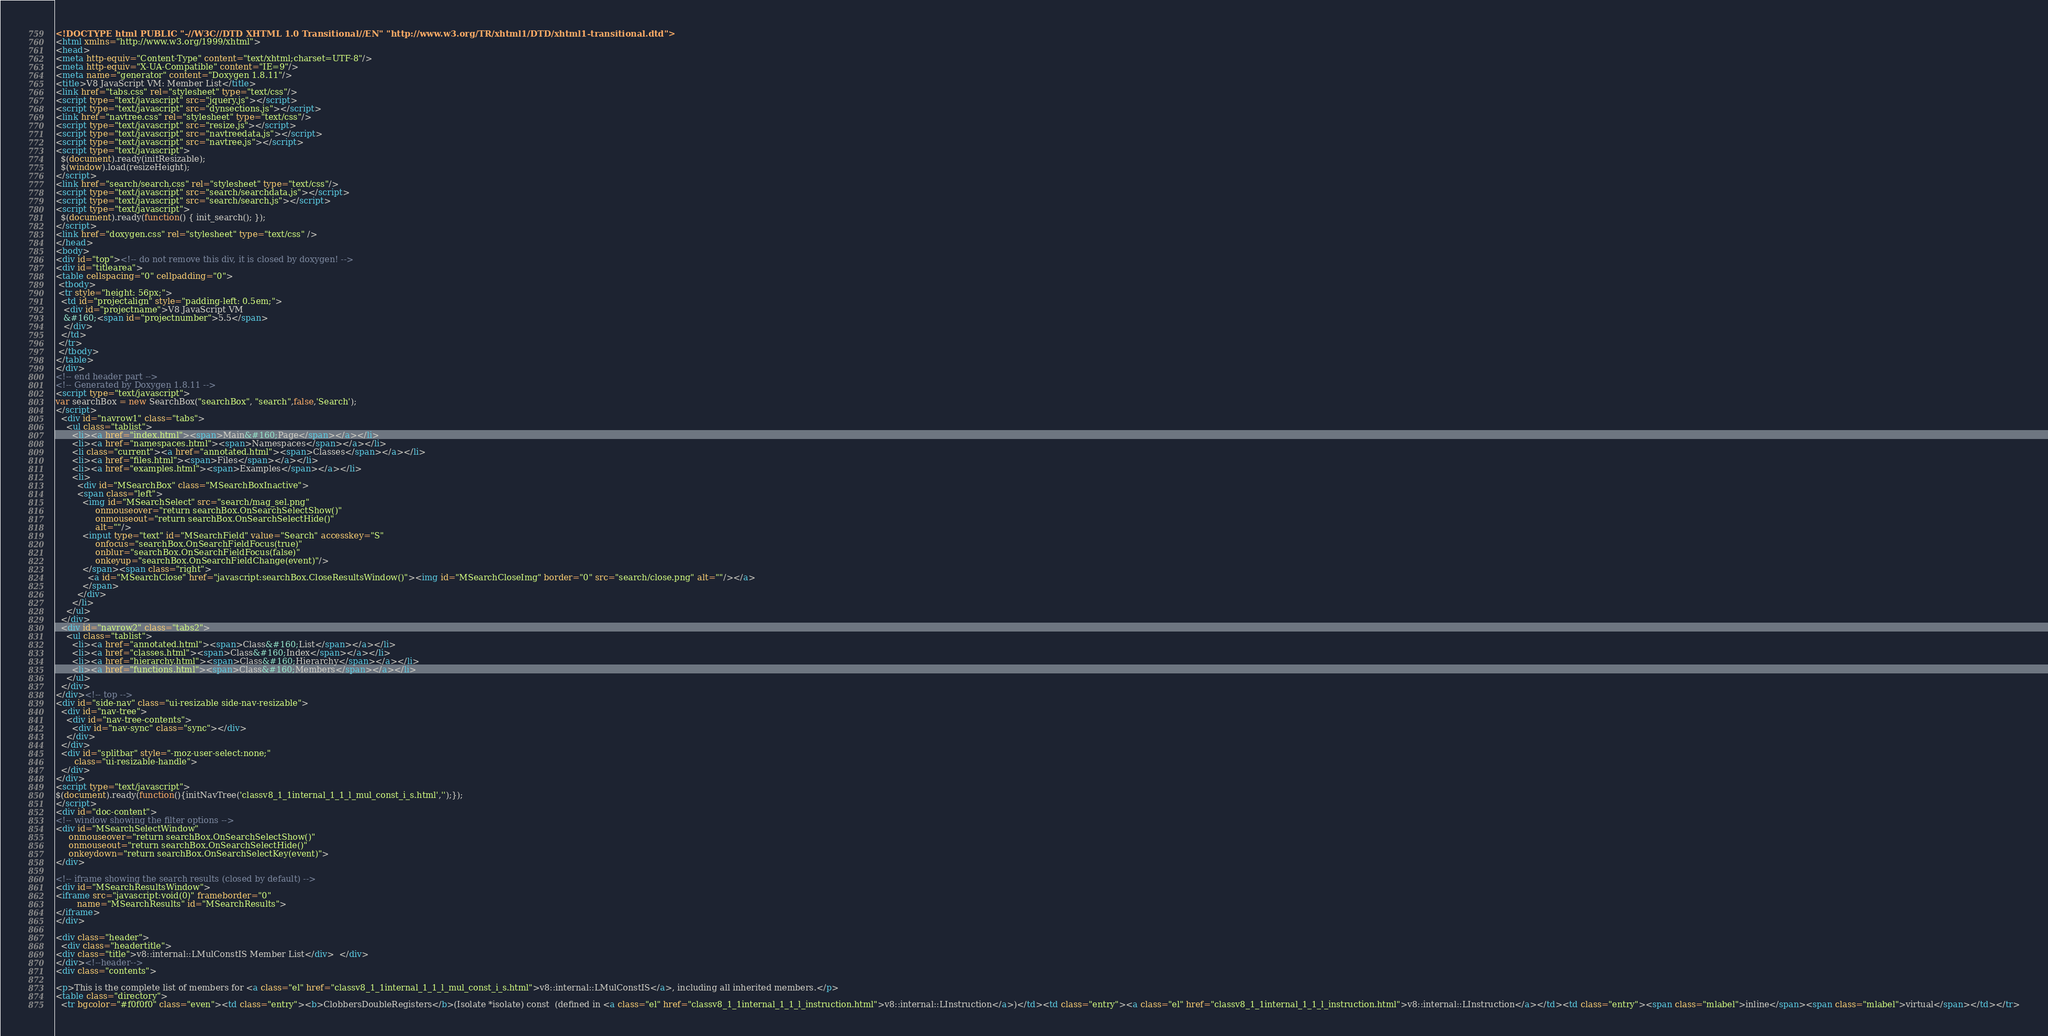<code> <loc_0><loc_0><loc_500><loc_500><_HTML_><!DOCTYPE html PUBLIC "-//W3C//DTD XHTML 1.0 Transitional//EN" "http://www.w3.org/TR/xhtml1/DTD/xhtml1-transitional.dtd">
<html xmlns="http://www.w3.org/1999/xhtml">
<head>
<meta http-equiv="Content-Type" content="text/xhtml;charset=UTF-8"/>
<meta http-equiv="X-UA-Compatible" content="IE=9"/>
<meta name="generator" content="Doxygen 1.8.11"/>
<title>V8 JavaScript VM: Member List</title>
<link href="tabs.css" rel="stylesheet" type="text/css"/>
<script type="text/javascript" src="jquery.js"></script>
<script type="text/javascript" src="dynsections.js"></script>
<link href="navtree.css" rel="stylesheet" type="text/css"/>
<script type="text/javascript" src="resize.js"></script>
<script type="text/javascript" src="navtreedata.js"></script>
<script type="text/javascript" src="navtree.js"></script>
<script type="text/javascript">
  $(document).ready(initResizable);
  $(window).load(resizeHeight);
</script>
<link href="search/search.css" rel="stylesheet" type="text/css"/>
<script type="text/javascript" src="search/searchdata.js"></script>
<script type="text/javascript" src="search/search.js"></script>
<script type="text/javascript">
  $(document).ready(function() { init_search(); });
</script>
<link href="doxygen.css" rel="stylesheet" type="text/css" />
</head>
<body>
<div id="top"><!-- do not remove this div, it is closed by doxygen! -->
<div id="titlearea">
<table cellspacing="0" cellpadding="0">
 <tbody>
 <tr style="height: 56px;">
  <td id="projectalign" style="padding-left: 0.5em;">
   <div id="projectname">V8 JavaScript VM
   &#160;<span id="projectnumber">5.5</span>
   </div>
  </td>
 </tr>
 </tbody>
</table>
</div>
<!-- end header part -->
<!-- Generated by Doxygen 1.8.11 -->
<script type="text/javascript">
var searchBox = new SearchBox("searchBox", "search",false,'Search');
</script>
  <div id="navrow1" class="tabs">
    <ul class="tablist">
      <li><a href="index.html"><span>Main&#160;Page</span></a></li>
      <li><a href="namespaces.html"><span>Namespaces</span></a></li>
      <li class="current"><a href="annotated.html"><span>Classes</span></a></li>
      <li><a href="files.html"><span>Files</span></a></li>
      <li><a href="examples.html"><span>Examples</span></a></li>
      <li>
        <div id="MSearchBox" class="MSearchBoxInactive">
        <span class="left">
          <img id="MSearchSelect" src="search/mag_sel.png"
               onmouseover="return searchBox.OnSearchSelectShow()"
               onmouseout="return searchBox.OnSearchSelectHide()"
               alt=""/>
          <input type="text" id="MSearchField" value="Search" accesskey="S"
               onfocus="searchBox.OnSearchFieldFocus(true)" 
               onblur="searchBox.OnSearchFieldFocus(false)" 
               onkeyup="searchBox.OnSearchFieldChange(event)"/>
          </span><span class="right">
            <a id="MSearchClose" href="javascript:searchBox.CloseResultsWindow()"><img id="MSearchCloseImg" border="0" src="search/close.png" alt=""/></a>
          </span>
        </div>
      </li>
    </ul>
  </div>
  <div id="navrow2" class="tabs2">
    <ul class="tablist">
      <li><a href="annotated.html"><span>Class&#160;List</span></a></li>
      <li><a href="classes.html"><span>Class&#160;Index</span></a></li>
      <li><a href="hierarchy.html"><span>Class&#160;Hierarchy</span></a></li>
      <li><a href="functions.html"><span>Class&#160;Members</span></a></li>
    </ul>
  </div>
</div><!-- top -->
<div id="side-nav" class="ui-resizable side-nav-resizable">
  <div id="nav-tree">
    <div id="nav-tree-contents">
      <div id="nav-sync" class="sync"></div>
    </div>
  </div>
  <div id="splitbar" style="-moz-user-select:none;" 
       class="ui-resizable-handle">
  </div>
</div>
<script type="text/javascript">
$(document).ready(function(){initNavTree('classv8_1_1internal_1_1_l_mul_const_i_s.html','');});
</script>
<div id="doc-content">
<!-- window showing the filter options -->
<div id="MSearchSelectWindow"
     onmouseover="return searchBox.OnSearchSelectShow()"
     onmouseout="return searchBox.OnSearchSelectHide()"
     onkeydown="return searchBox.OnSearchSelectKey(event)">
</div>

<!-- iframe showing the search results (closed by default) -->
<div id="MSearchResultsWindow">
<iframe src="javascript:void(0)" frameborder="0" 
        name="MSearchResults" id="MSearchResults">
</iframe>
</div>

<div class="header">
  <div class="headertitle">
<div class="title">v8::internal::LMulConstIS Member List</div>  </div>
</div><!--header-->
<div class="contents">

<p>This is the complete list of members for <a class="el" href="classv8_1_1internal_1_1_l_mul_const_i_s.html">v8::internal::LMulConstIS</a>, including all inherited members.</p>
<table class="directory">
  <tr bgcolor="#f0f0f0" class="even"><td class="entry"><b>ClobbersDoubleRegisters</b>(Isolate *isolate) const  (defined in <a class="el" href="classv8_1_1internal_1_1_l_instruction.html">v8::internal::LInstruction</a>)</td><td class="entry"><a class="el" href="classv8_1_1internal_1_1_l_instruction.html">v8::internal::LInstruction</a></td><td class="entry"><span class="mlabel">inline</span><span class="mlabel">virtual</span></td></tr></code> 